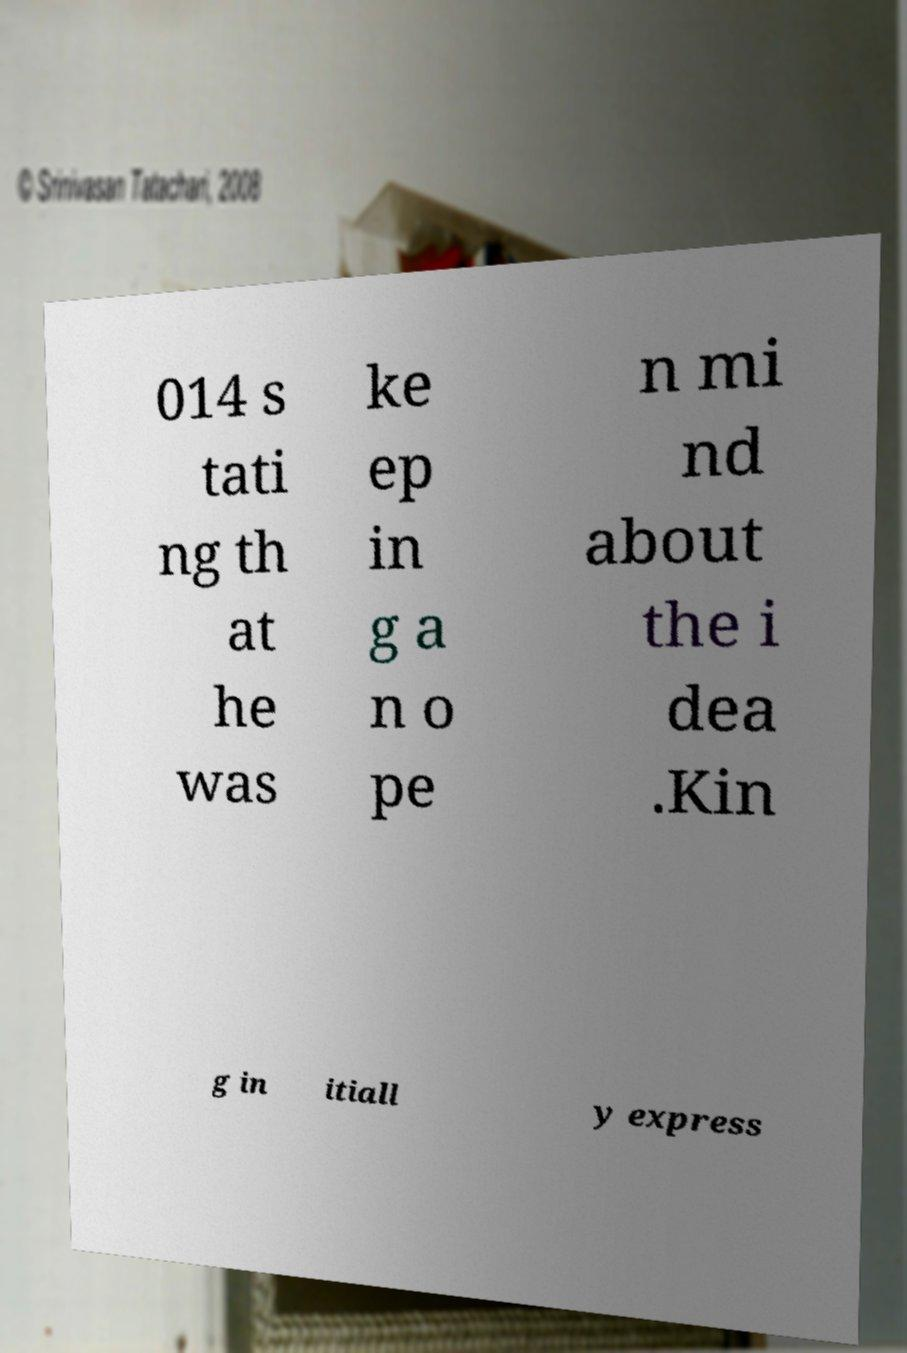Can you read and provide the text displayed in the image?This photo seems to have some interesting text. Can you extract and type it out for me? 014 s tati ng th at he was ke ep in g a n o pe n mi nd about the i dea .Kin g in itiall y express 